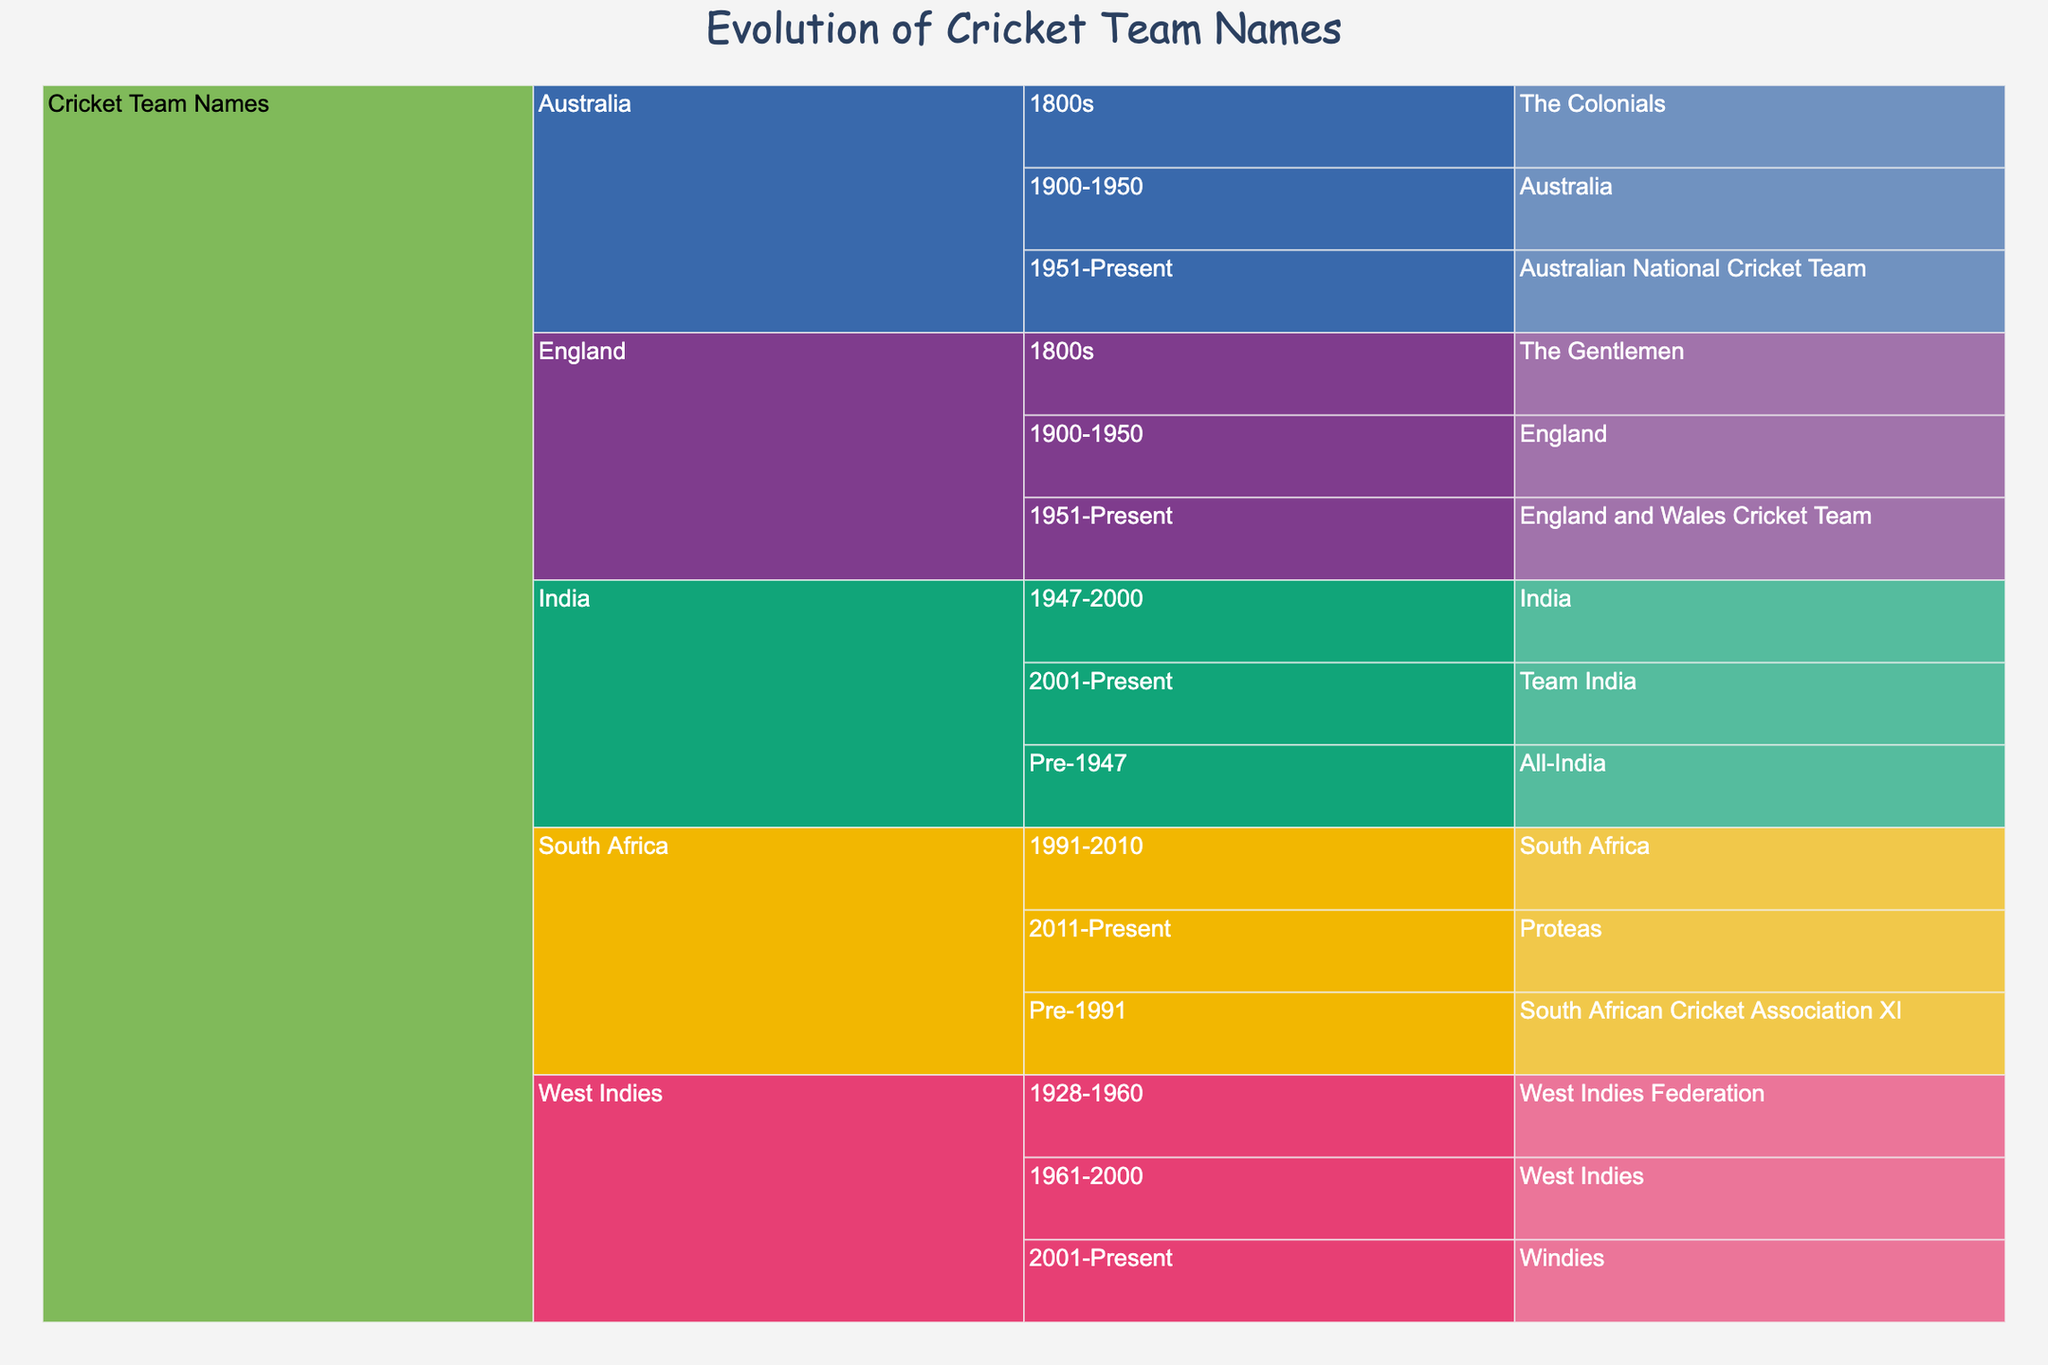What is the title of the figure? The title is usually shown at the top center of the plot. Here, it is labeled "Evolution of Cricket Team Names".
Answer: Evolution of Cricket Team Names How many time periods are there for the Australian cricket team? The Australian cricket team's timeline can be found by following the path from the "Root" to "Country" (Australia) and then checking the "Era" subdivisions. There are three periods: 1800s, 1900-1950, and 1951-Present.
Answer: 3 Which country's cricket team name is "Proteas" in the present time? By looking for "Proteas" within the "Team Name" section, we can trace back to see that it is under "South Africa" and in the "2011-Present" era.
Answer: South Africa In which era was the West Indies cricket team called "West Indies Federation"? To find this, locate "West Indies Federation" under "Team Name", and trace it to the "Era" column, which shows "1928-1960".
Answer: 1928-1960 Compare the number of name changes between the Indian and English cricket teams. Which team had more changes? The Indian team had three names (All-India, India, Team India) spanning Pre-1947, 1947-2000, and 2001-Present. The English team had three names (The Gentlemen, England, England and Wales Cricket Team) covering 1800s, 1900-1950, and 1951-Present. Both teams had the same number of name changes.
Answer: Both had the same Which cricket team had the name "The Gentlemen"? By locating "The Gentlemen" in the "Team Name" section, we can trace it back to "Country" and "Era", revealing it is the England team in the 1800s era.
Answer: England What is the current name for West Indies cricket team? Look for the entry under the "Team Name" column for "West Indies" in the "2001-Present" era, which is "Windies".
Answer: Windies In which era did "Australia" become the official name for the Australian cricket team? Follow the path from "Australia" in the "Team Name" column and check the corresponding "Era" column entry, which is "1900-1950".
Answer: 1900-1950 